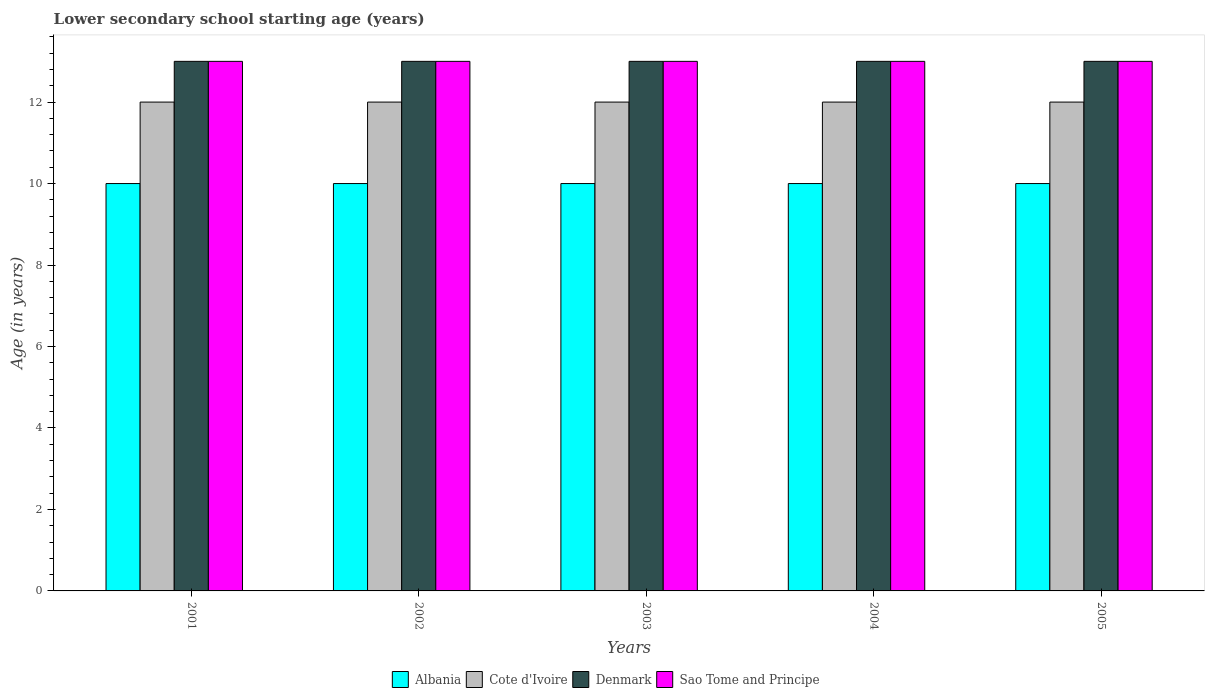How many different coloured bars are there?
Make the answer very short. 4. How many groups of bars are there?
Your answer should be compact. 5. Are the number of bars per tick equal to the number of legend labels?
Give a very brief answer. Yes. How many bars are there on the 5th tick from the left?
Provide a short and direct response. 4. In how many cases, is the number of bars for a given year not equal to the number of legend labels?
Ensure brevity in your answer.  0. What is the lower secondary school starting age of children in Sao Tome and Principe in 2005?
Ensure brevity in your answer.  13. Across all years, what is the maximum lower secondary school starting age of children in Denmark?
Ensure brevity in your answer.  13. Across all years, what is the minimum lower secondary school starting age of children in Cote d'Ivoire?
Ensure brevity in your answer.  12. In which year was the lower secondary school starting age of children in Albania maximum?
Your response must be concise. 2001. What is the total lower secondary school starting age of children in Denmark in the graph?
Ensure brevity in your answer.  65. In how many years, is the lower secondary school starting age of children in Cote d'Ivoire greater than 6 years?
Ensure brevity in your answer.  5. What is the ratio of the lower secondary school starting age of children in Albania in 2001 to that in 2004?
Ensure brevity in your answer.  1. Is the lower secondary school starting age of children in Cote d'Ivoire in 2002 less than that in 2004?
Your response must be concise. No. Is the difference between the lower secondary school starting age of children in Albania in 2001 and 2002 greater than the difference between the lower secondary school starting age of children in Denmark in 2001 and 2002?
Ensure brevity in your answer.  No. What does the 4th bar from the left in 2003 represents?
Ensure brevity in your answer.  Sao Tome and Principe. What does the 4th bar from the right in 2005 represents?
Make the answer very short. Albania. Is it the case that in every year, the sum of the lower secondary school starting age of children in Sao Tome and Principe and lower secondary school starting age of children in Albania is greater than the lower secondary school starting age of children in Denmark?
Make the answer very short. Yes. Are the values on the major ticks of Y-axis written in scientific E-notation?
Make the answer very short. No. Does the graph contain any zero values?
Your response must be concise. No. What is the title of the graph?
Offer a terse response. Lower secondary school starting age (years). What is the label or title of the Y-axis?
Ensure brevity in your answer.  Age (in years). What is the Age (in years) of Albania in 2001?
Your answer should be compact. 10. What is the Age (in years) of Denmark in 2001?
Provide a succinct answer. 13. What is the Age (in years) in Sao Tome and Principe in 2001?
Offer a terse response. 13. What is the Age (in years) of Cote d'Ivoire in 2002?
Ensure brevity in your answer.  12. What is the Age (in years) of Denmark in 2002?
Your response must be concise. 13. What is the Age (in years) in Albania in 2003?
Provide a short and direct response. 10. What is the Age (in years) of Cote d'Ivoire in 2003?
Provide a short and direct response. 12. What is the Age (in years) of Denmark in 2003?
Your answer should be very brief. 13. What is the Age (in years) of Sao Tome and Principe in 2003?
Keep it short and to the point. 13. What is the Age (in years) of Albania in 2004?
Offer a terse response. 10. What is the Age (in years) of Cote d'Ivoire in 2004?
Give a very brief answer. 12. What is the Age (in years) of Sao Tome and Principe in 2004?
Your answer should be compact. 13. What is the Age (in years) of Albania in 2005?
Ensure brevity in your answer.  10. What is the Age (in years) in Cote d'Ivoire in 2005?
Your response must be concise. 12. Across all years, what is the maximum Age (in years) of Albania?
Your answer should be compact. 10. Across all years, what is the maximum Age (in years) in Sao Tome and Principe?
Offer a terse response. 13. Across all years, what is the minimum Age (in years) of Albania?
Ensure brevity in your answer.  10. Across all years, what is the minimum Age (in years) of Cote d'Ivoire?
Offer a terse response. 12. What is the total Age (in years) of Albania in the graph?
Your response must be concise. 50. What is the total Age (in years) in Cote d'Ivoire in the graph?
Your response must be concise. 60. What is the total Age (in years) of Denmark in the graph?
Ensure brevity in your answer.  65. What is the difference between the Age (in years) of Albania in 2001 and that in 2002?
Keep it short and to the point. 0. What is the difference between the Age (in years) in Denmark in 2001 and that in 2002?
Provide a short and direct response. 0. What is the difference between the Age (in years) in Sao Tome and Principe in 2001 and that in 2002?
Provide a short and direct response. 0. What is the difference between the Age (in years) of Denmark in 2001 and that in 2003?
Your answer should be very brief. 0. What is the difference between the Age (in years) of Sao Tome and Principe in 2001 and that in 2003?
Provide a succinct answer. 0. What is the difference between the Age (in years) in Cote d'Ivoire in 2001 and that in 2005?
Your answer should be very brief. 0. What is the difference between the Age (in years) in Denmark in 2001 and that in 2005?
Give a very brief answer. 0. What is the difference between the Age (in years) of Sao Tome and Principe in 2001 and that in 2005?
Offer a very short reply. 0. What is the difference between the Age (in years) of Denmark in 2002 and that in 2003?
Provide a succinct answer. 0. What is the difference between the Age (in years) of Sao Tome and Principe in 2002 and that in 2003?
Offer a very short reply. 0. What is the difference between the Age (in years) of Albania in 2002 and that in 2004?
Give a very brief answer. 0. What is the difference between the Age (in years) of Sao Tome and Principe in 2002 and that in 2004?
Your answer should be very brief. 0. What is the difference between the Age (in years) in Albania in 2002 and that in 2005?
Your response must be concise. 0. What is the difference between the Age (in years) of Cote d'Ivoire in 2003 and that in 2004?
Give a very brief answer. 0. What is the difference between the Age (in years) in Denmark in 2003 and that in 2005?
Your answer should be very brief. 0. What is the difference between the Age (in years) of Albania in 2004 and that in 2005?
Keep it short and to the point. 0. What is the difference between the Age (in years) in Cote d'Ivoire in 2004 and that in 2005?
Your answer should be very brief. 0. What is the difference between the Age (in years) of Denmark in 2004 and that in 2005?
Keep it short and to the point. 0. What is the difference between the Age (in years) of Albania in 2001 and the Age (in years) of Cote d'Ivoire in 2002?
Your answer should be compact. -2. What is the difference between the Age (in years) of Albania in 2001 and the Age (in years) of Sao Tome and Principe in 2002?
Your answer should be very brief. -3. What is the difference between the Age (in years) in Cote d'Ivoire in 2001 and the Age (in years) in Denmark in 2002?
Offer a terse response. -1. What is the difference between the Age (in years) of Cote d'Ivoire in 2001 and the Age (in years) of Sao Tome and Principe in 2002?
Your answer should be compact. -1. What is the difference between the Age (in years) of Albania in 2001 and the Age (in years) of Denmark in 2003?
Your answer should be very brief. -3. What is the difference between the Age (in years) in Cote d'Ivoire in 2001 and the Age (in years) in Denmark in 2003?
Offer a very short reply. -1. What is the difference between the Age (in years) in Albania in 2001 and the Age (in years) in Cote d'Ivoire in 2004?
Your response must be concise. -2. What is the difference between the Age (in years) of Albania in 2001 and the Age (in years) of Sao Tome and Principe in 2004?
Give a very brief answer. -3. What is the difference between the Age (in years) in Cote d'Ivoire in 2001 and the Age (in years) in Sao Tome and Principe in 2004?
Your answer should be compact. -1. What is the difference between the Age (in years) of Denmark in 2001 and the Age (in years) of Sao Tome and Principe in 2004?
Keep it short and to the point. 0. What is the difference between the Age (in years) of Albania in 2001 and the Age (in years) of Denmark in 2005?
Ensure brevity in your answer.  -3. What is the difference between the Age (in years) of Albania in 2001 and the Age (in years) of Sao Tome and Principe in 2005?
Your answer should be compact. -3. What is the difference between the Age (in years) of Albania in 2002 and the Age (in years) of Cote d'Ivoire in 2003?
Keep it short and to the point. -2. What is the difference between the Age (in years) in Albania in 2002 and the Age (in years) in Denmark in 2003?
Give a very brief answer. -3. What is the difference between the Age (in years) of Albania in 2002 and the Age (in years) of Sao Tome and Principe in 2003?
Give a very brief answer. -3. What is the difference between the Age (in years) of Cote d'Ivoire in 2002 and the Age (in years) of Sao Tome and Principe in 2003?
Your answer should be very brief. -1. What is the difference between the Age (in years) of Denmark in 2002 and the Age (in years) of Sao Tome and Principe in 2003?
Offer a very short reply. 0. What is the difference between the Age (in years) of Albania in 2002 and the Age (in years) of Denmark in 2004?
Your answer should be very brief. -3. What is the difference between the Age (in years) in Cote d'Ivoire in 2002 and the Age (in years) in Sao Tome and Principe in 2004?
Ensure brevity in your answer.  -1. What is the difference between the Age (in years) of Albania in 2002 and the Age (in years) of Denmark in 2005?
Your answer should be compact. -3. What is the difference between the Age (in years) of Albania in 2002 and the Age (in years) of Sao Tome and Principe in 2005?
Keep it short and to the point. -3. What is the difference between the Age (in years) of Cote d'Ivoire in 2002 and the Age (in years) of Denmark in 2005?
Keep it short and to the point. -1. What is the difference between the Age (in years) of Denmark in 2002 and the Age (in years) of Sao Tome and Principe in 2005?
Keep it short and to the point. 0. What is the difference between the Age (in years) in Denmark in 2003 and the Age (in years) in Sao Tome and Principe in 2004?
Make the answer very short. 0. What is the difference between the Age (in years) in Cote d'Ivoire in 2003 and the Age (in years) in Denmark in 2005?
Your answer should be very brief. -1. What is the difference between the Age (in years) of Cote d'Ivoire in 2003 and the Age (in years) of Sao Tome and Principe in 2005?
Your answer should be compact. -1. What is the difference between the Age (in years) of Albania in 2004 and the Age (in years) of Denmark in 2005?
Your answer should be compact. -3. What is the difference between the Age (in years) in Cote d'Ivoire in 2004 and the Age (in years) in Denmark in 2005?
Keep it short and to the point. -1. What is the difference between the Age (in years) of Cote d'Ivoire in 2004 and the Age (in years) of Sao Tome and Principe in 2005?
Ensure brevity in your answer.  -1. What is the difference between the Age (in years) in Denmark in 2004 and the Age (in years) in Sao Tome and Principe in 2005?
Offer a very short reply. 0. What is the average Age (in years) in Albania per year?
Ensure brevity in your answer.  10. In the year 2001, what is the difference between the Age (in years) of Albania and Age (in years) of Cote d'Ivoire?
Make the answer very short. -2. In the year 2002, what is the difference between the Age (in years) of Albania and Age (in years) of Denmark?
Make the answer very short. -3. In the year 2002, what is the difference between the Age (in years) in Cote d'Ivoire and Age (in years) in Sao Tome and Principe?
Ensure brevity in your answer.  -1. In the year 2002, what is the difference between the Age (in years) in Denmark and Age (in years) in Sao Tome and Principe?
Offer a very short reply. 0. In the year 2003, what is the difference between the Age (in years) of Albania and Age (in years) of Denmark?
Keep it short and to the point. -3. In the year 2003, what is the difference between the Age (in years) of Cote d'Ivoire and Age (in years) of Denmark?
Keep it short and to the point. -1. In the year 2003, what is the difference between the Age (in years) of Cote d'Ivoire and Age (in years) of Sao Tome and Principe?
Your answer should be very brief. -1. In the year 2004, what is the difference between the Age (in years) of Albania and Age (in years) of Cote d'Ivoire?
Offer a terse response. -2. In the year 2004, what is the difference between the Age (in years) in Albania and Age (in years) in Denmark?
Provide a short and direct response. -3. In the year 2004, what is the difference between the Age (in years) of Albania and Age (in years) of Sao Tome and Principe?
Ensure brevity in your answer.  -3. In the year 2004, what is the difference between the Age (in years) of Cote d'Ivoire and Age (in years) of Sao Tome and Principe?
Provide a succinct answer. -1. In the year 2004, what is the difference between the Age (in years) of Denmark and Age (in years) of Sao Tome and Principe?
Provide a succinct answer. 0. In the year 2005, what is the difference between the Age (in years) of Albania and Age (in years) of Cote d'Ivoire?
Give a very brief answer. -2. In the year 2005, what is the difference between the Age (in years) in Cote d'Ivoire and Age (in years) in Denmark?
Your response must be concise. -1. In the year 2005, what is the difference between the Age (in years) of Cote d'Ivoire and Age (in years) of Sao Tome and Principe?
Ensure brevity in your answer.  -1. In the year 2005, what is the difference between the Age (in years) in Denmark and Age (in years) in Sao Tome and Principe?
Your answer should be compact. 0. What is the ratio of the Age (in years) in Albania in 2001 to that in 2002?
Your answer should be very brief. 1. What is the ratio of the Age (in years) in Denmark in 2001 to that in 2002?
Offer a very short reply. 1. What is the ratio of the Age (in years) in Sao Tome and Principe in 2001 to that in 2002?
Your answer should be very brief. 1. What is the ratio of the Age (in years) in Albania in 2001 to that in 2003?
Make the answer very short. 1. What is the ratio of the Age (in years) of Cote d'Ivoire in 2001 to that in 2003?
Ensure brevity in your answer.  1. What is the ratio of the Age (in years) of Sao Tome and Principe in 2001 to that in 2003?
Your answer should be very brief. 1. What is the ratio of the Age (in years) in Cote d'Ivoire in 2001 to that in 2004?
Offer a very short reply. 1. What is the ratio of the Age (in years) of Albania in 2001 to that in 2005?
Your answer should be very brief. 1. What is the ratio of the Age (in years) of Denmark in 2001 to that in 2005?
Provide a short and direct response. 1. What is the ratio of the Age (in years) of Albania in 2002 to that in 2003?
Keep it short and to the point. 1. What is the ratio of the Age (in years) in Cote d'Ivoire in 2002 to that in 2003?
Make the answer very short. 1. What is the ratio of the Age (in years) in Sao Tome and Principe in 2002 to that in 2003?
Provide a succinct answer. 1. What is the ratio of the Age (in years) in Denmark in 2002 to that in 2004?
Ensure brevity in your answer.  1. What is the ratio of the Age (in years) of Albania in 2002 to that in 2005?
Make the answer very short. 1. What is the ratio of the Age (in years) of Cote d'Ivoire in 2002 to that in 2005?
Provide a succinct answer. 1. What is the ratio of the Age (in years) in Albania in 2003 to that in 2004?
Offer a terse response. 1. What is the ratio of the Age (in years) of Cote d'Ivoire in 2003 to that in 2004?
Make the answer very short. 1. What is the ratio of the Age (in years) of Sao Tome and Principe in 2003 to that in 2004?
Provide a succinct answer. 1. What is the ratio of the Age (in years) in Albania in 2003 to that in 2005?
Offer a terse response. 1. What is the ratio of the Age (in years) in Sao Tome and Principe in 2003 to that in 2005?
Provide a succinct answer. 1. What is the ratio of the Age (in years) of Albania in 2004 to that in 2005?
Ensure brevity in your answer.  1. What is the ratio of the Age (in years) in Denmark in 2004 to that in 2005?
Keep it short and to the point. 1. What is the difference between the highest and the lowest Age (in years) in Albania?
Offer a very short reply. 0. What is the difference between the highest and the lowest Age (in years) in Cote d'Ivoire?
Give a very brief answer. 0. 